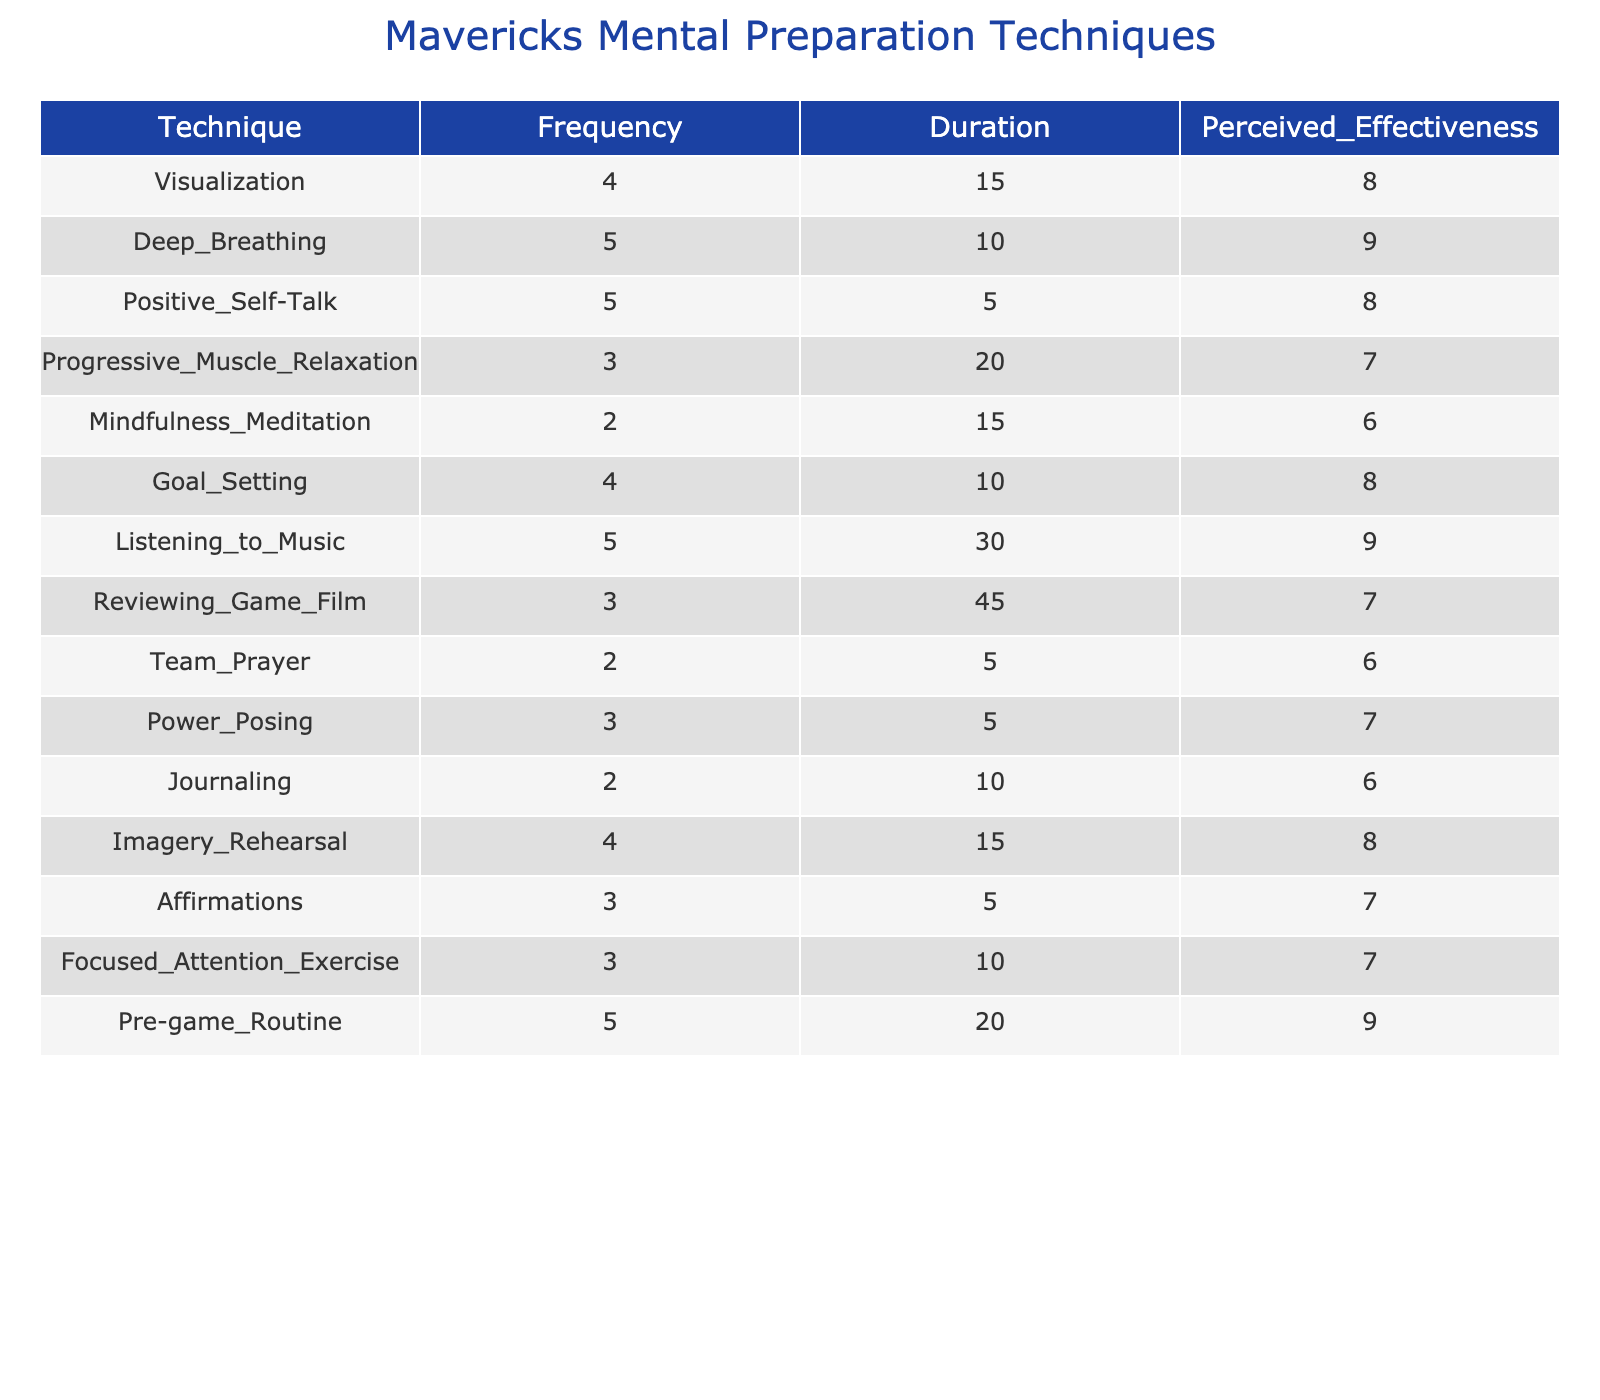What is the most frequently used mental preparation technique before games? The table shows that Deep Breathing and Listening to Music both have a frequency of 5, which is the highest in the list.
Answer: Deep Breathing and Listening to Music What is the perceived effectiveness of Progress Muscle Relaxation? According to the table, the perceived effectiveness for Progressive Muscle Relaxation is listed as 7.
Answer: 7 Which technique has the longest average duration in minutes? The duration for Reviewing Game Film is 45 minutes, which is the longest compared to the other techniques listed.
Answer: Reviewing Game Film What is the average perceived effectiveness of all techniques listed? To calculate the average, we sum the perceived effectiveness values (8 + 9 + 8 + 7 + 6 + 8 + 9 + 7 + 6 + 7 + 6 + 8 + 7 + 7 + 9) which equals 107, then divide by 15 (the number of techniques), giving us an average of approximately 7.13.
Answer: 7.13 Is there any technique with a frequency of less than 3? By examining the table, Mindfulness Meditation and Team Prayer are the only techniques with a frequency of 2, which confirms the answer.
Answer: Yes What techniques have a perceived effectiveness of 8 or more? The techniques with a perceived effectiveness of 8 or more are Visualization, Deep Breathing, Positive Self-Talk, Goal Setting, Listening to Music, Imagery Rehearsal, and Pre-game Routine. Counting these, there are 7 such techniques.
Answer: 7 techniques What is the total duration spent on Deep Breathing and Positive Self-Talk combined? The durations for Deep Breathing and Positive Self-Talk are 10 minutes and 5 minutes respectively. Adding these provides a total duration of 15 minutes.
Answer: 15 minutes Which technique has a higher perceived effectiveness: Affirmations or Power Posing? From the table, Affirmations have a perceived effectiveness of 7, while Power Posing also has a perceived effectiveness of 7. Thus, they are equal in effectiveness.
Answer: Equal How does the frequency of Pre-game Routine compare to Mindfulness Meditation? The frequency of Pre-game Routine is 5 while Mindfulness Meditation has a frequency of 2, indicating that Pre-game Routine is used more frequently than Mindfulness Meditation.
Answer: Pre-game Routine is used more frequently 